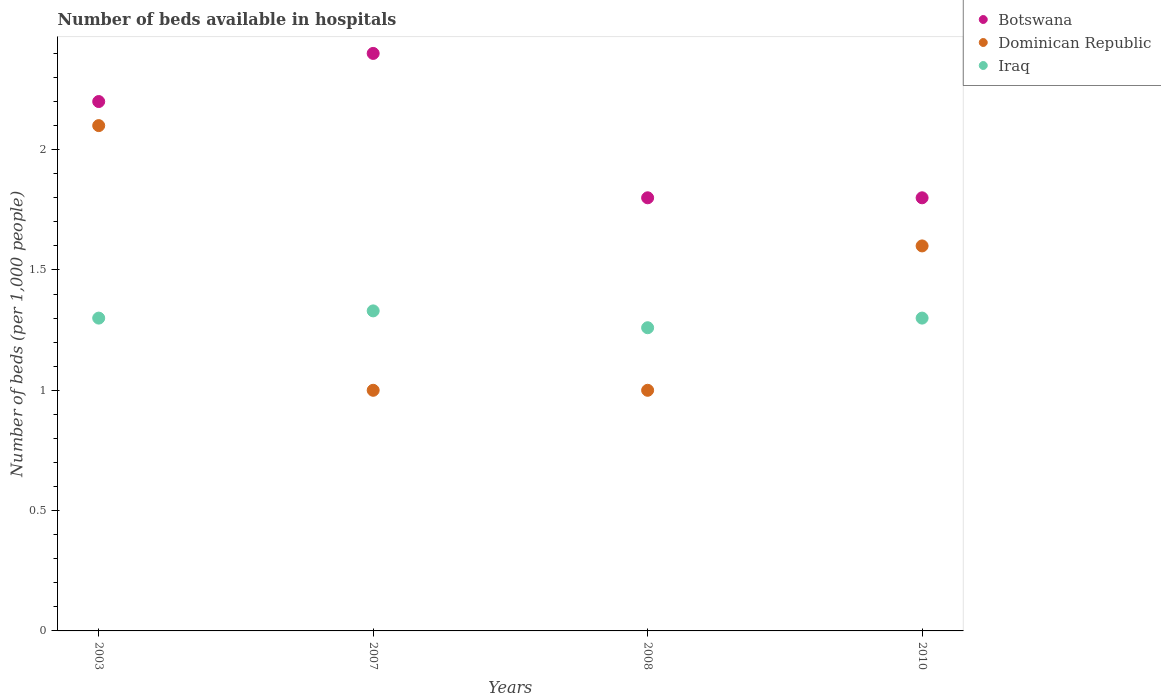How many different coloured dotlines are there?
Make the answer very short. 3. Is the number of dotlines equal to the number of legend labels?
Your response must be concise. Yes. Across all years, what is the maximum number of beds in the hospiatls of in Iraq?
Your answer should be compact. 1.33. In which year was the number of beds in the hospiatls of in Dominican Republic maximum?
Your response must be concise. 2003. In which year was the number of beds in the hospiatls of in Botswana minimum?
Make the answer very short. 2008. What is the difference between the number of beds in the hospiatls of in Dominican Republic in 2007 and that in 2010?
Make the answer very short. -0.6. What is the difference between the number of beds in the hospiatls of in Iraq in 2008 and the number of beds in the hospiatls of in Dominican Republic in 2010?
Your answer should be very brief. -0.34. What is the average number of beds in the hospiatls of in Dominican Republic per year?
Offer a very short reply. 1.42. In how many years, is the number of beds in the hospiatls of in Botswana greater than 0.6?
Provide a short and direct response. 4. What is the ratio of the number of beds in the hospiatls of in Botswana in 2003 to that in 2007?
Provide a short and direct response. 0.92. Is the number of beds in the hospiatls of in Botswana in 2003 less than that in 2008?
Keep it short and to the point. No. What is the difference between the highest and the second highest number of beds in the hospiatls of in Dominican Republic?
Offer a terse response. 0.5. What is the difference between the highest and the lowest number of beds in the hospiatls of in Dominican Republic?
Your answer should be compact. 1.1. Is the sum of the number of beds in the hospiatls of in Botswana in 2007 and 2010 greater than the maximum number of beds in the hospiatls of in Iraq across all years?
Offer a terse response. Yes. Is the number of beds in the hospiatls of in Botswana strictly less than the number of beds in the hospiatls of in Iraq over the years?
Keep it short and to the point. No. What is the difference between two consecutive major ticks on the Y-axis?
Provide a succinct answer. 0.5. Does the graph contain any zero values?
Your response must be concise. No. How many legend labels are there?
Provide a short and direct response. 3. How are the legend labels stacked?
Your response must be concise. Vertical. What is the title of the graph?
Offer a terse response. Number of beds available in hospitals. Does "Guinea" appear as one of the legend labels in the graph?
Give a very brief answer. No. What is the label or title of the X-axis?
Ensure brevity in your answer.  Years. What is the label or title of the Y-axis?
Ensure brevity in your answer.  Number of beds (per 1,0 people). What is the Number of beds (per 1,000 people) of Botswana in 2003?
Make the answer very short. 2.2. What is the Number of beds (per 1,000 people) of Dominican Republic in 2003?
Your answer should be very brief. 2.1. What is the Number of beds (per 1,000 people) in Iraq in 2003?
Your answer should be compact. 1.3. What is the Number of beds (per 1,000 people) in Botswana in 2007?
Ensure brevity in your answer.  2.4. What is the Number of beds (per 1,000 people) in Iraq in 2007?
Provide a short and direct response. 1.33. What is the Number of beds (per 1,000 people) in Dominican Republic in 2008?
Provide a short and direct response. 1. What is the Number of beds (per 1,000 people) of Iraq in 2008?
Give a very brief answer. 1.26. What is the Number of beds (per 1,000 people) of Botswana in 2010?
Your response must be concise. 1.8. Across all years, what is the maximum Number of beds (per 1,000 people) of Dominican Republic?
Offer a terse response. 2.1. Across all years, what is the maximum Number of beds (per 1,000 people) of Iraq?
Offer a terse response. 1.33. Across all years, what is the minimum Number of beds (per 1,000 people) of Botswana?
Give a very brief answer. 1.8. Across all years, what is the minimum Number of beds (per 1,000 people) in Dominican Republic?
Offer a terse response. 1. Across all years, what is the minimum Number of beds (per 1,000 people) of Iraq?
Make the answer very short. 1.26. What is the total Number of beds (per 1,000 people) in Botswana in the graph?
Ensure brevity in your answer.  8.2. What is the total Number of beds (per 1,000 people) of Dominican Republic in the graph?
Provide a succinct answer. 5.7. What is the total Number of beds (per 1,000 people) in Iraq in the graph?
Provide a short and direct response. 5.19. What is the difference between the Number of beds (per 1,000 people) in Botswana in 2003 and that in 2007?
Your answer should be compact. -0.2. What is the difference between the Number of beds (per 1,000 people) in Dominican Republic in 2003 and that in 2007?
Keep it short and to the point. 1.1. What is the difference between the Number of beds (per 1,000 people) of Iraq in 2003 and that in 2007?
Your response must be concise. -0.03. What is the difference between the Number of beds (per 1,000 people) of Dominican Republic in 2003 and that in 2008?
Offer a very short reply. 1.1. What is the difference between the Number of beds (per 1,000 people) of Iraq in 2003 and that in 2010?
Offer a very short reply. -0. What is the difference between the Number of beds (per 1,000 people) of Dominican Republic in 2007 and that in 2008?
Give a very brief answer. 0. What is the difference between the Number of beds (per 1,000 people) of Iraq in 2007 and that in 2008?
Your answer should be very brief. 0.07. What is the difference between the Number of beds (per 1,000 people) of Botswana in 2007 and that in 2010?
Keep it short and to the point. 0.6. What is the difference between the Number of beds (per 1,000 people) of Dominican Republic in 2007 and that in 2010?
Provide a succinct answer. -0.6. What is the difference between the Number of beds (per 1,000 people) of Iraq in 2007 and that in 2010?
Provide a short and direct response. 0.03. What is the difference between the Number of beds (per 1,000 people) in Dominican Republic in 2008 and that in 2010?
Your answer should be very brief. -0.6. What is the difference between the Number of beds (per 1,000 people) of Iraq in 2008 and that in 2010?
Provide a short and direct response. -0.04. What is the difference between the Number of beds (per 1,000 people) in Botswana in 2003 and the Number of beds (per 1,000 people) in Iraq in 2007?
Make the answer very short. 0.87. What is the difference between the Number of beds (per 1,000 people) of Dominican Republic in 2003 and the Number of beds (per 1,000 people) of Iraq in 2007?
Give a very brief answer. 0.77. What is the difference between the Number of beds (per 1,000 people) of Botswana in 2003 and the Number of beds (per 1,000 people) of Dominican Republic in 2008?
Make the answer very short. 1.2. What is the difference between the Number of beds (per 1,000 people) of Botswana in 2003 and the Number of beds (per 1,000 people) of Iraq in 2008?
Provide a short and direct response. 0.94. What is the difference between the Number of beds (per 1,000 people) of Dominican Republic in 2003 and the Number of beds (per 1,000 people) of Iraq in 2008?
Ensure brevity in your answer.  0.84. What is the difference between the Number of beds (per 1,000 people) of Botswana in 2003 and the Number of beds (per 1,000 people) of Dominican Republic in 2010?
Give a very brief answer. 0.6. What is the difference between the Number of beds (per 1,000 people) of Botswana in 2003 and the Number of beds (per 1,000 people) of Iraq in 2010?
Your response must be concise. 0.9. What is the difference between the Number of beds (per 1,000 people) in Botswana in 2007 and the Number of beds (per 1,000 people) in Iraq in 2008?
Give a very brief answer. 1.14. What is the difference between the Number of beds (per 1,000 people) in Dominican Republic in 2007 and the Number of beds (per 1,000 people) in Iraq in 2008?
Offer a terse response. -0.26. What is the difference between the Number of beds (per 1,000 people) in Botswana in 2007 and the Number of beds (per 1,000 people) in Dominican Republic in 2010?
Keep it short and to the point. 0.8. What is the difference between the Number of beds (per 1,000 people) in Dominican Republic in 2007 and the Number of beds (per 1,000 people) in Iraq in 2010?
Make the answer very short. -0.3. What is the difference between the Number of beds (per 1,000 people) of Botswana in 2008 and the Number of beds (per 1,000 people) of Iraq in 2010?
Give a very brief answer. 0.5. What is the average Number of beds (per 1,000 people) in Botswana per year?
Your answer should be very brief. 2.05. What is the average Number of beds (per 1,000 people) of Dominican Republic per year?
Keep it short and to the point. 1.43. What is the average Number of beds (per 1,000 people) of Iraq per year?
Give a very brief answer. 1.3. In the year 2003, what is the difference between the Number of beds (per 1,000 people) of Dominican Republic and Number of beds (per 1,000 people) of Iraq?
Provide a succinct answer. 0.8. In the year 2007, what is the difference between the Number of beds (per 1,000 people) in Botswana and Number of beds (per 1,000 people) in Iraq?
Provide a short and direct response. 1.07. In the year 2007, what is the difference between the Number of beds (per 1,000 people) of Dominican Republic and Number of beds (per 1,000 people) of Iraq?
Ensure brevity in your answer.  -0.33. In the year 2008, what is the difference between the Number of beds (per 1,000 people) of Botswana and Number of beds (per 1,000 people) of Iraq?
Your answer should be very brief. 0.54. In the year 2008, what is the difference between the Number of beds (per 1,000 people) of Dominican Republic and Number of beds (per 1,000 people) of Iraq?
Give a very brief answer. -0.26. What is the ratio of the Number of beds (per 1,000 people) of Dominican Republic in 2003 to that in 2007?
Your answer should be very brief. 2.1. What is the ratio of the Number of beds (per 1,000 people) in Iraq in 2003 to that in 2007?
Make the answer very short. 0.98. What is the ratio of the Number of beds (per 1,000 people) of Botswana in 2003 to that in 2008?
Ensure brevity in your answer.  1.22. What is the ratio of the Number of beds (per 1,000 people) of Dominican Republic in 2003 to that in 2008?
Make the answer very short. 2.1. What is the ratio of the Number of beds (per 1,000 people) of Iraq in 2003 to that in 2008?
Provide a succinct answer. 1.03. What is the ratio of the Number of beds (per 1,000 people) of Botswana in 2003 to that in 2010?
Give a very brief answer. 1.22. What is the ratio of the Number of beds (per 1,000 people) of Dominican Republic in 2003 to that in 2010?
Keep it short and to the point. 1.31. What is the ratio of the Number of beds (per 1,000 people) of Botswana in 2007 to that in 2008?
Offer a terse response. 1.33. What is the ratio of the Number of beds (per 1,000 people) of Iraq in 2007 to that in 2008?
Give a very brief answer. 1.06. What is the ratio of the Number of beds (per 1,000 people) in Botswana in 2007 to that in 2010?
Make the answer very short. 1.33. What is the ratio of the Number of beds (per 1,000 people) in Dominican Republic in 2007 to that in 2010?
Offer a very short reply. 0.62. What is the ratio of the Number of beds (per 1,000 people) of Iraq in 2007 to that in 2010?
Your response must be concise. 1.02. What is the ratio of the Number of beds (per 1,000 people) of Iraq in 2008 to that in 2010?
Your answer should be compact. 0.97. What is the difference between the highest and the second highest Number of beds (per 1,000 people) of Botswana?
Offer a very short reply. 0.2. What is the difference between the highest and the second highest Number of beds (per 1,000 people) of Dominican Republic?
Your response must be concise. 0.5. What is the difference between the highest and the second highest Number of beds (per 1,000 people) in Iraq?
Provide a succinct answer. 0.03. What is the difference between the highest and the lowest Number of beds (per 1,000 people) in Iraq?
Ensure brevity in your answer.  0.07. 